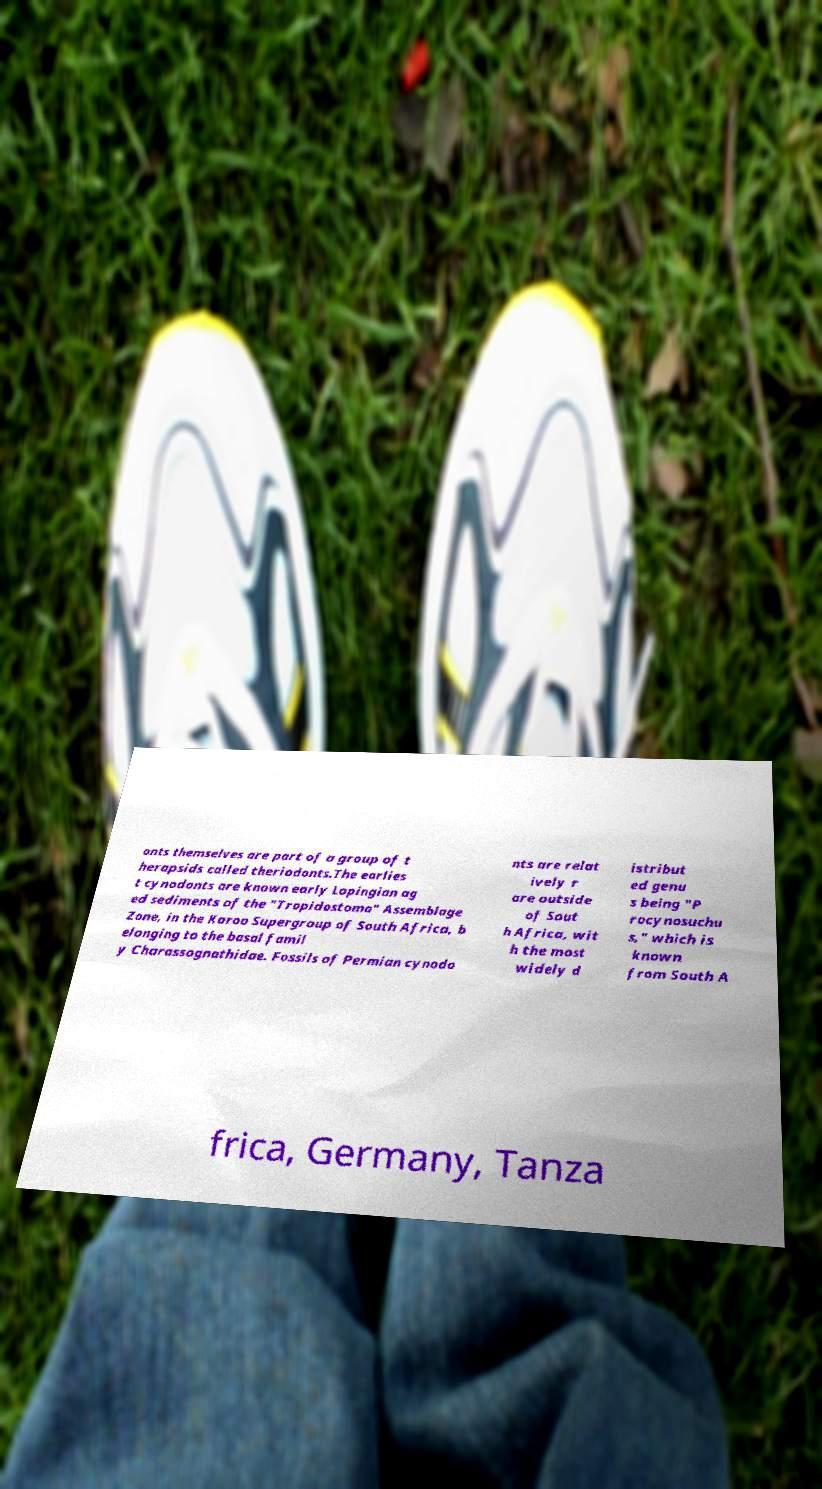Please read and relay the text visible in this image. What does it say? onts themselves are part of a group of t herapsids called theriodonts.The earlies t cynodonts are known early Lopingian ag ed sediments of the "Tropidostoma" Assemblage Zone, in the Karoo Supergroup of South Africa, b elonging to the basal famil y Charassognathidae. Fossils of Permian cynodo nts are relat ively r are outside of Sout h Africa, wit h the most widely d istribut ed genu s being "P rocynosuchu s," which is known from South A frica, Germany, Tanza 